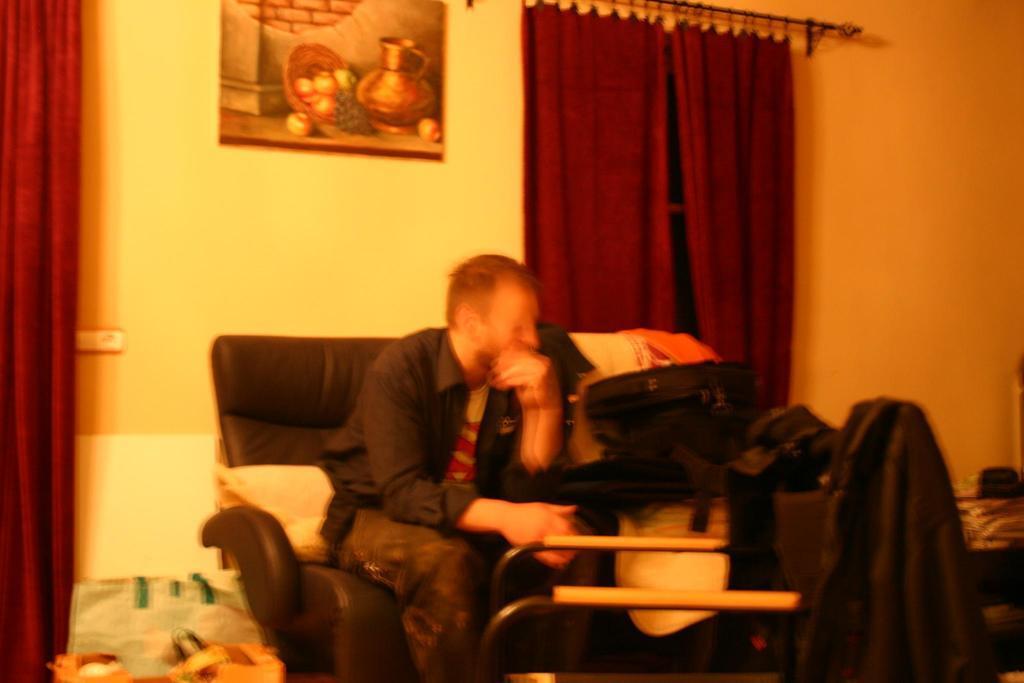How would you summarize this image in a sentence or two? In this picture we can see a man sitting on a chair, bags, clothes, curtains, frame on the wall and some objects. 